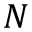<formula> <loc_0><loc_0><loc_500><loc_500>N</formula> 